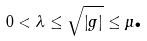Convert formula to latex. <formula><loc_0><loc_0><loc_500><loc_500>0 < \lambda \leq \sqrt { \left | g \right | } \leq \mu \text {.}</formula> 